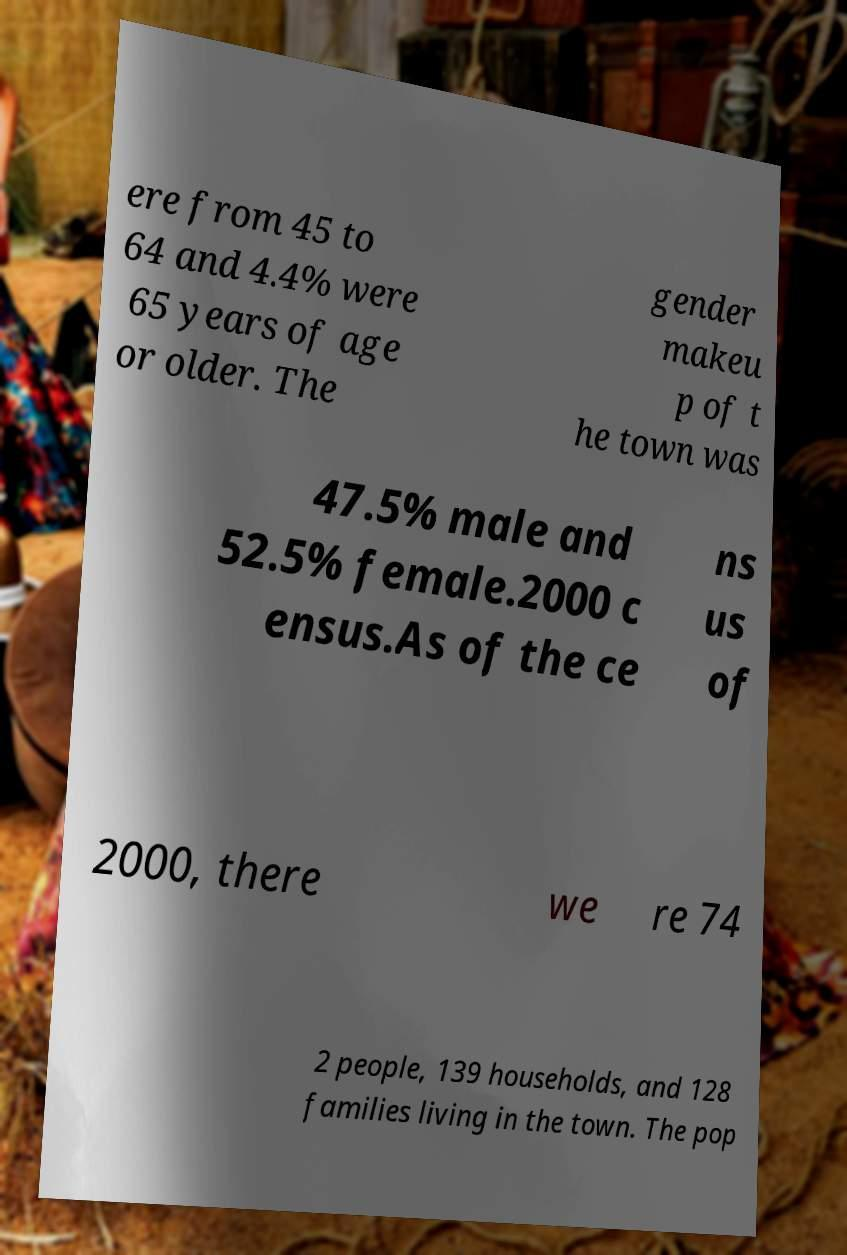Could you extract and type out the text from this image? ere from 45 to 64 and 4.4% were 65 years of age or older. The gender makeu p of t he town was 47.5% male and 52.5% female.2000 c ensus.As of the ce ns us of 2000, there we re 74 2 people, 139 households, and 128 families living in the town. The pop 